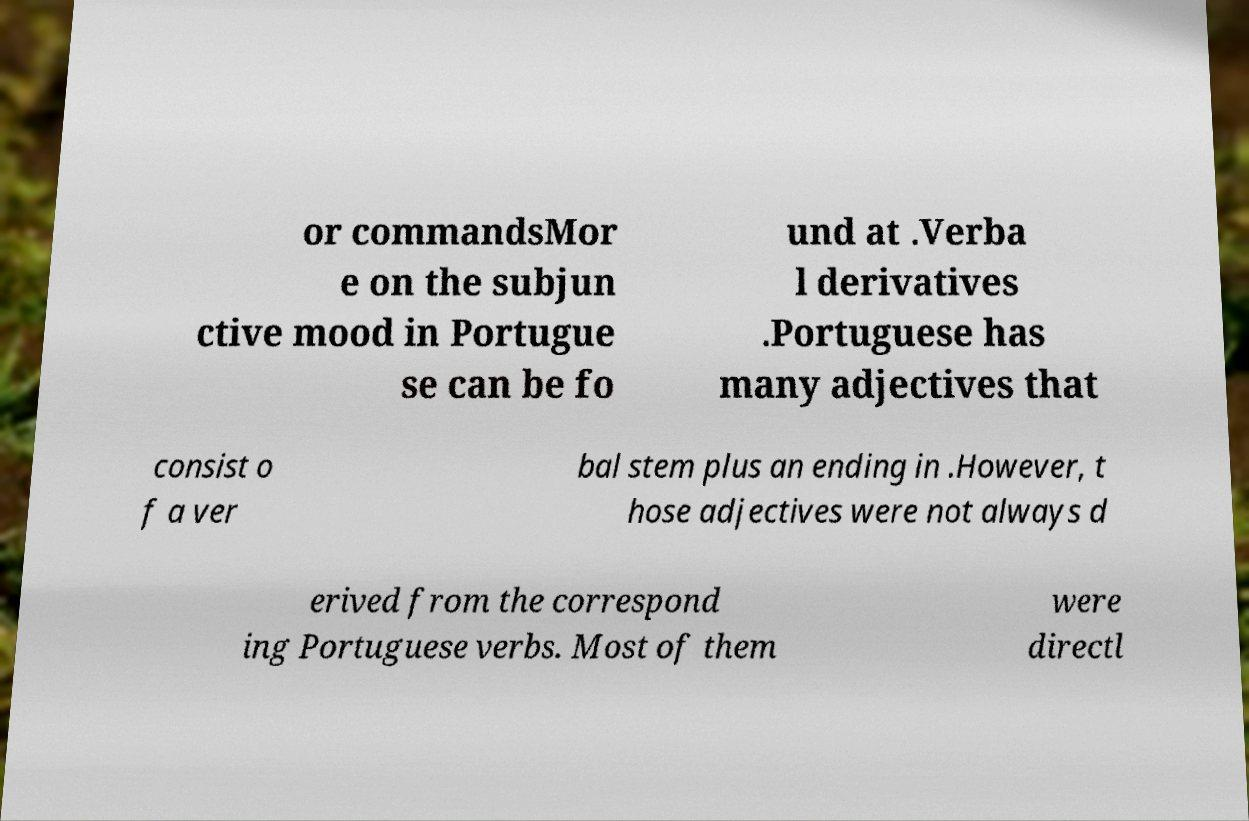I need the written content from this picture converted into text. Can you do that? or commandsMor e on the subjun ctive mood in Portugue se can be fo und at .Verba l derivatives .Portuguese has many adjectives that consist o f a ver bal stem plus an ending in .However, t hose adjectives were not always d erived from the correspond ing Portuguese verbs. Most of them were directl 